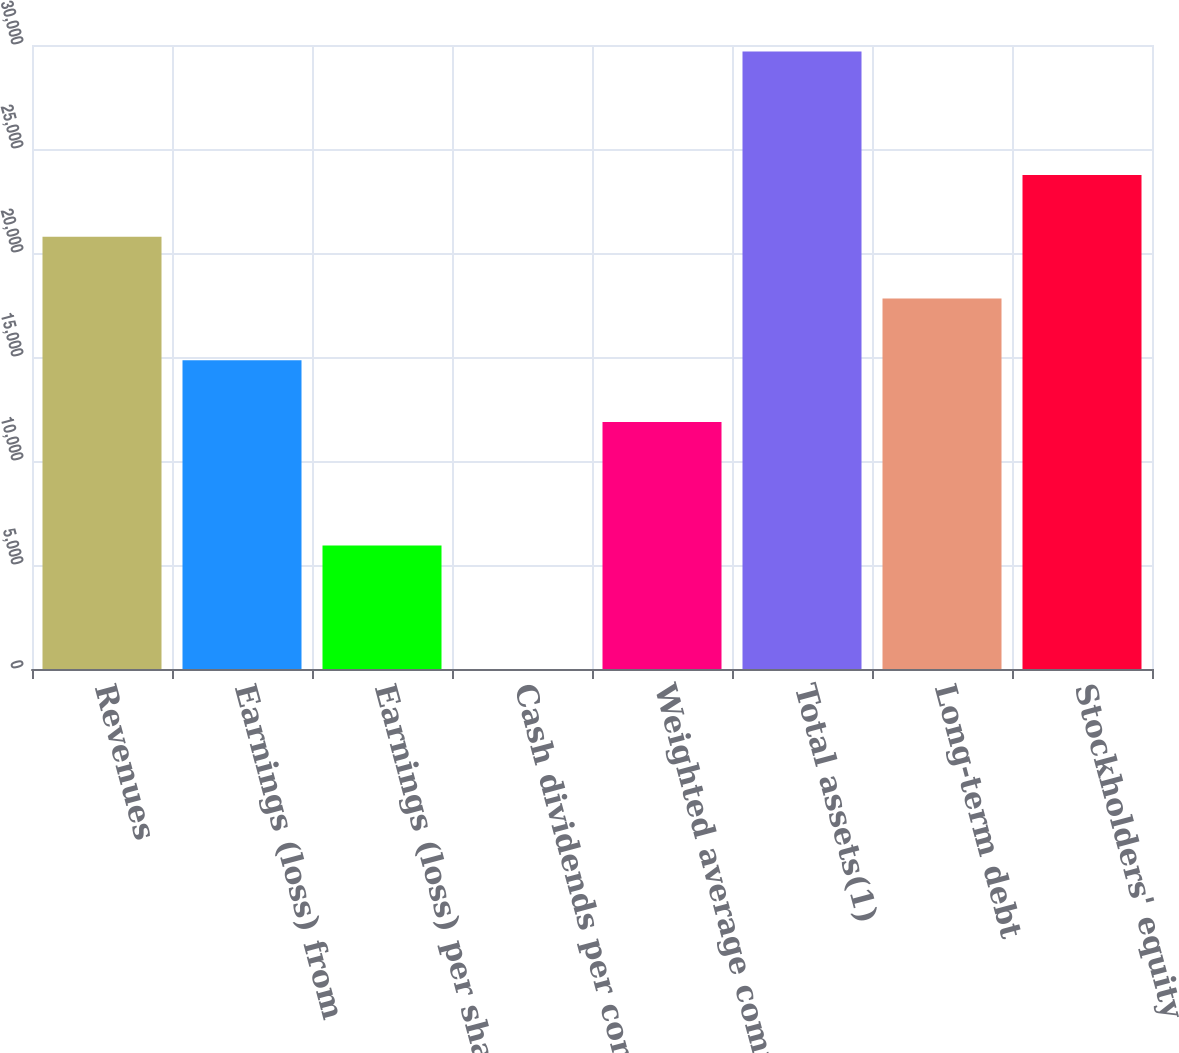Convert chart to OTSL. <chart><loc_0><loc_0><loc_500><loc_500><bar_chart><fcel>Revenues<fcel>Earnings (loss) from<fcel>Earnings (loss) per share from<fcel>Cash dividends per common<fcel>Weighted average common shares<fcel>Total assets(1)<fcel>Long-term debt<fcel>Stockholders' equity<nl><fcel>20780.4<fcel>14843.3<fcel>5937.72<fcel>0.64<fcel>11874.8<fcel>29686<fcel>17811.9<fcel>23749<nl></chart> 